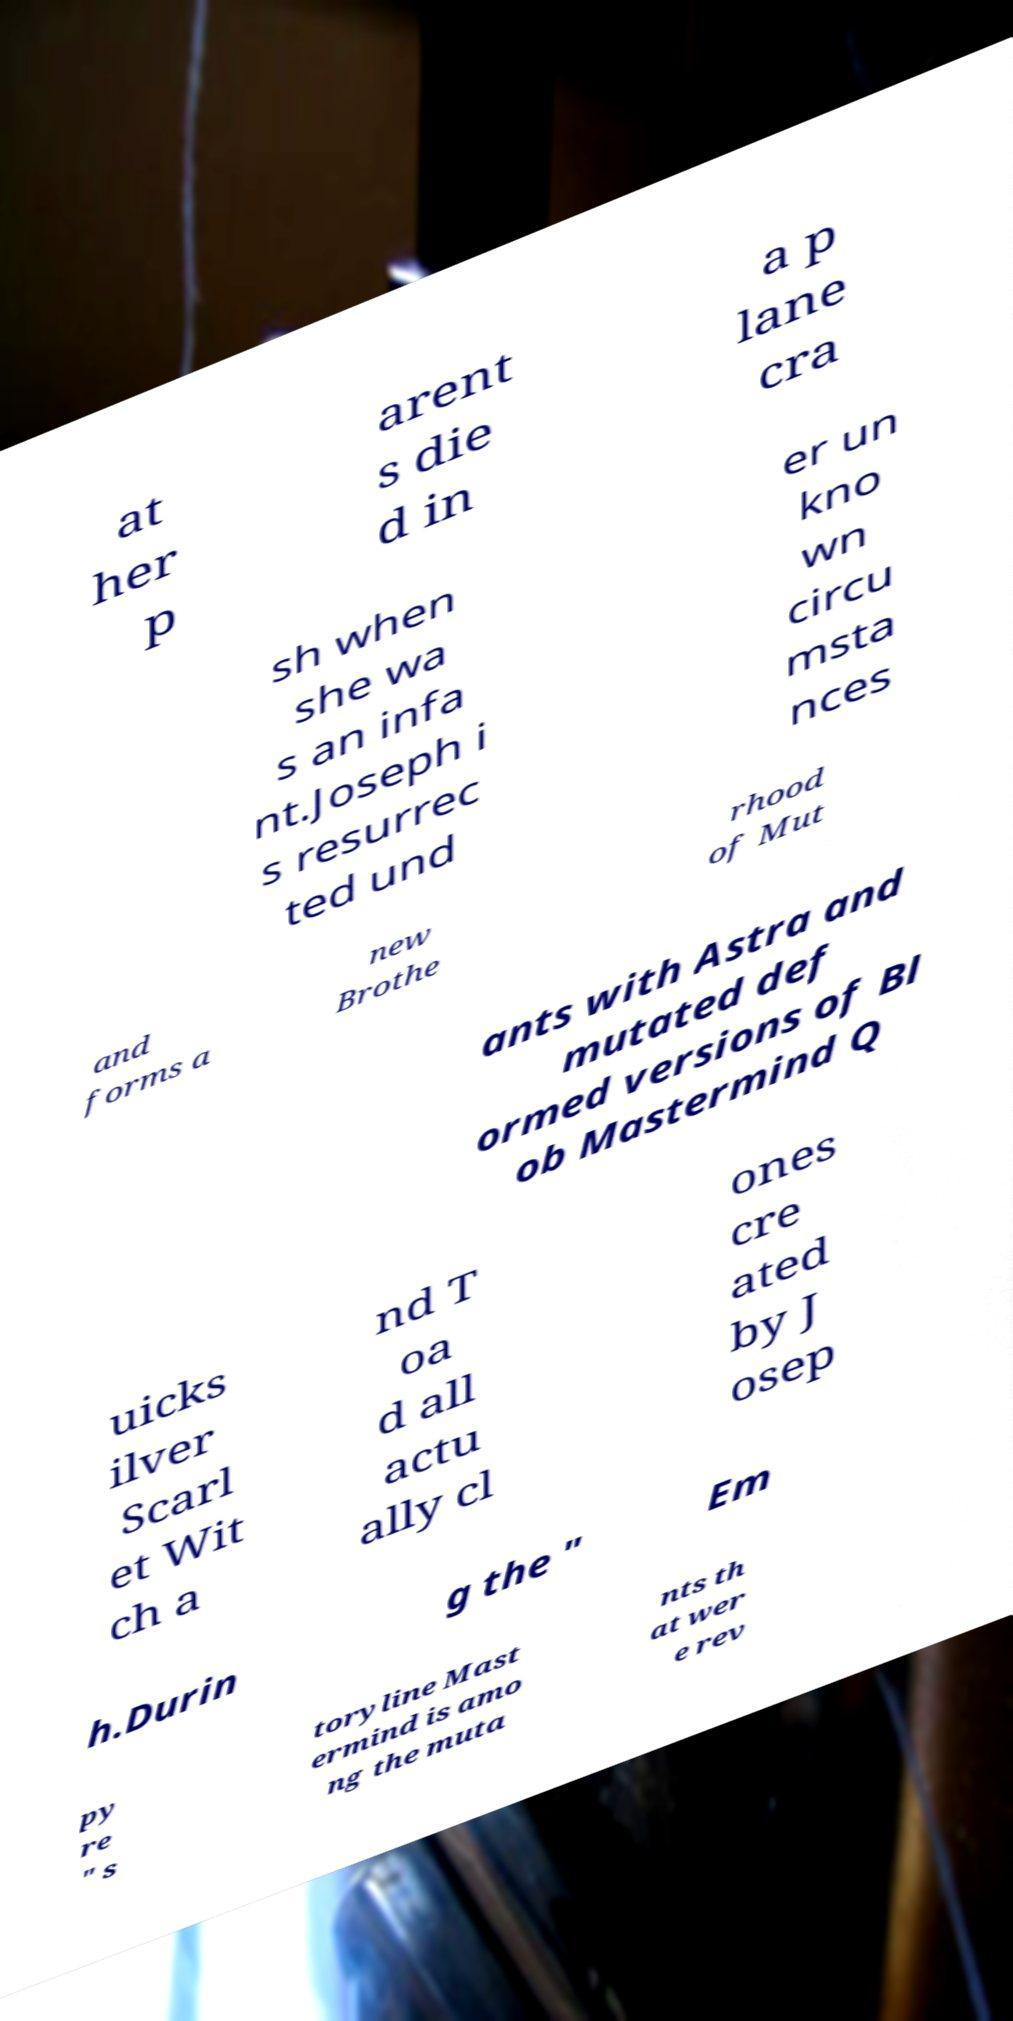Please identify and transcribe the text found in this image. at her p arent s die d in a p lane cra sh when she wa s an infa nt.Joseph i s resurrec ted und er un kno wn circu msta nces and forms a new Brothe rhood of Mut ants with Astra and mutated def ormed versions of Bl ob Mastermind Q uicks ilver Scarl et Wit ch a nd T oa d all actu ally cl ones cre ated by J osep h.Durin g the " Em py re " s toryline Mast ermind is amo ng the muta nts th at wer e rev 